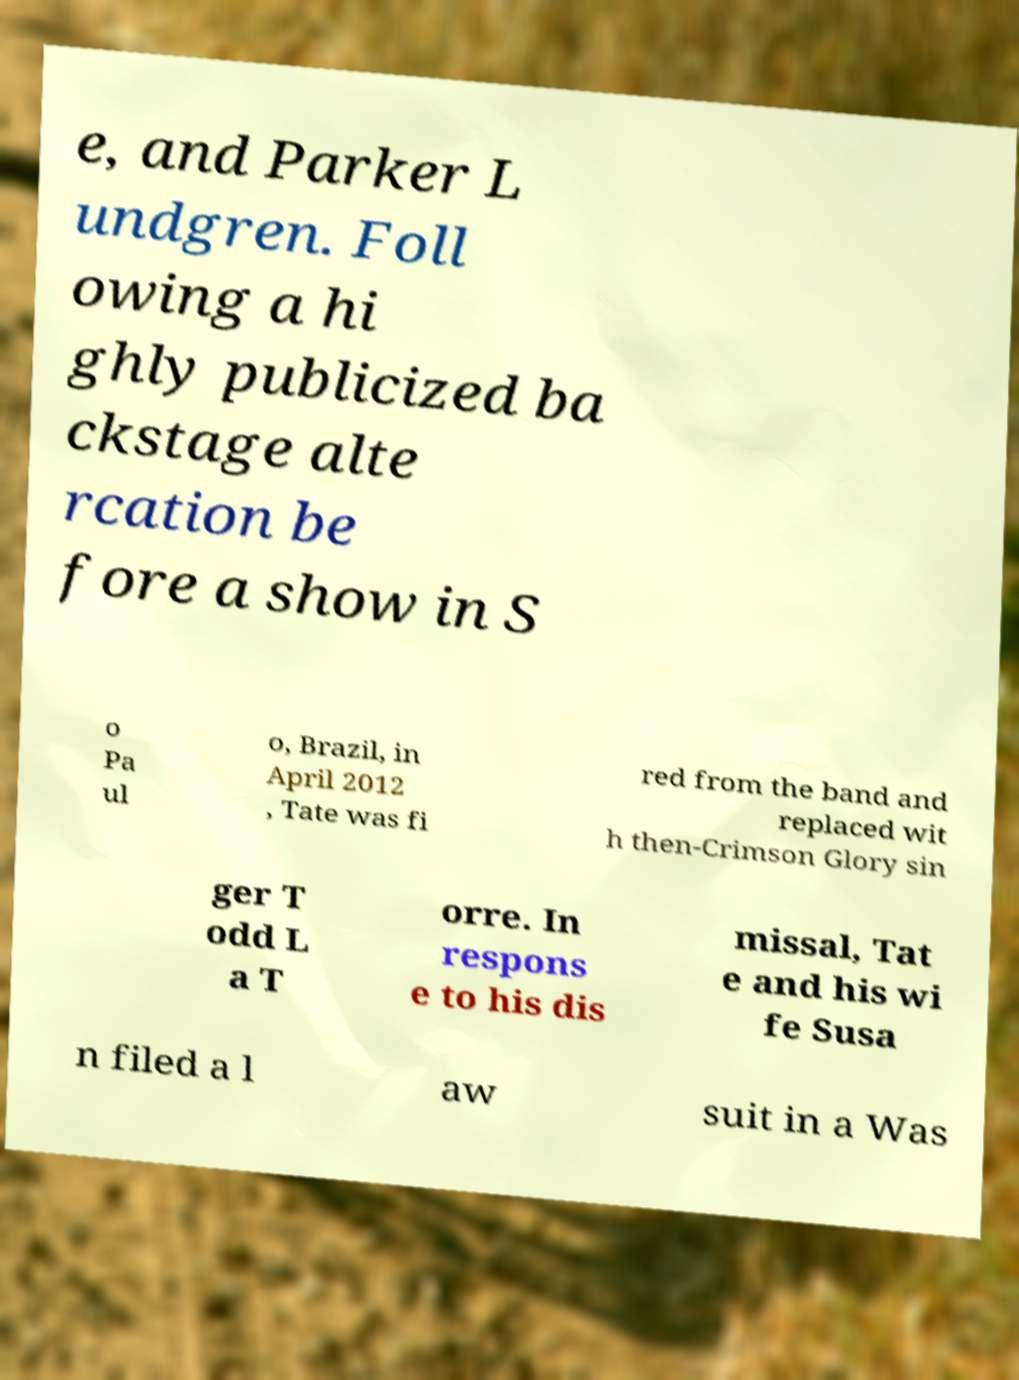There's text embedded in this image that I need extracted. Can you transcribe it verbatim? e, and Parker L undgren. Foll owing a hi ghly publicized ba ckstage alte rcation be fore a show in S o Pa ul o, Brazil, in April 2012 , Tate was fi red from the band and replaced wit h then-Crimson Glory sin ger T odd L a T orre. In respons e to his dis missal, Tat e and his wi fe Susa n filed a l aw suit in a Was 